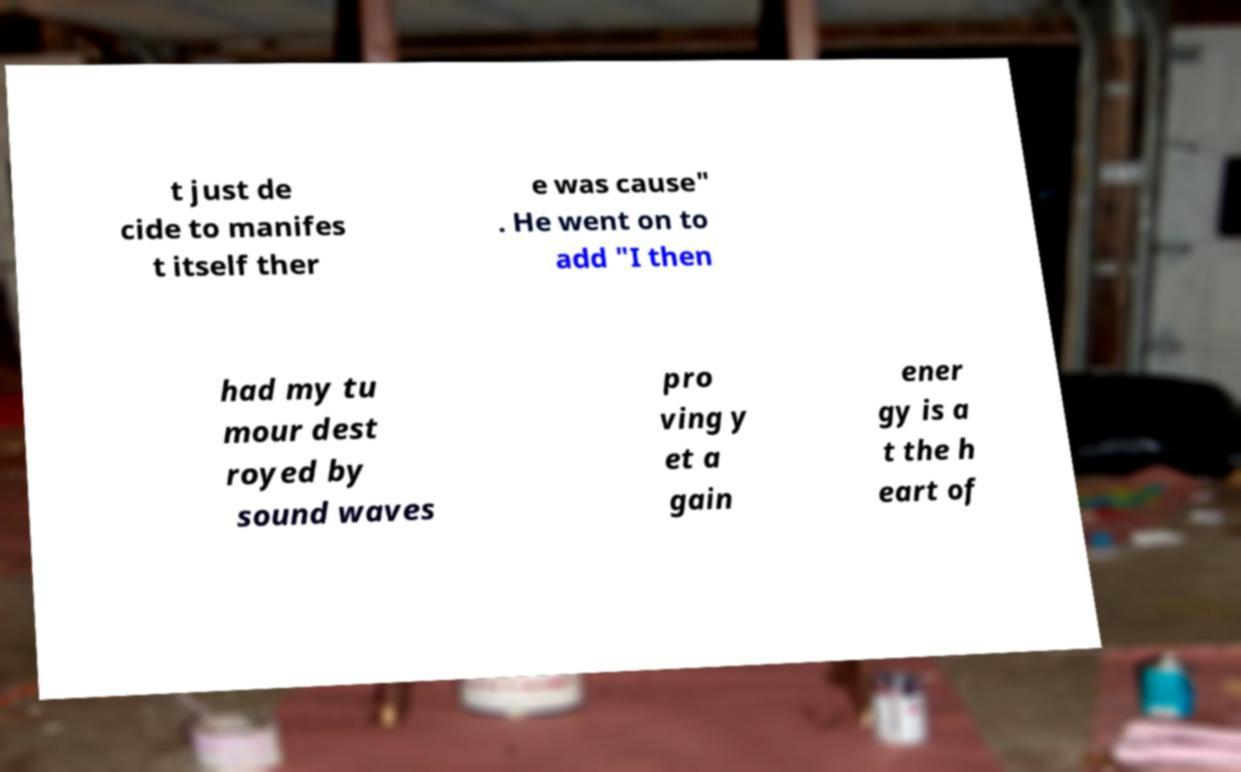Could you extract and type out the text from this image? t just de cide to manifes t itself ther e was cause" . He went on to add "I then had my tu mour dest royed by sound waves pro ving y et a gain ener gy is a t the h eart of 